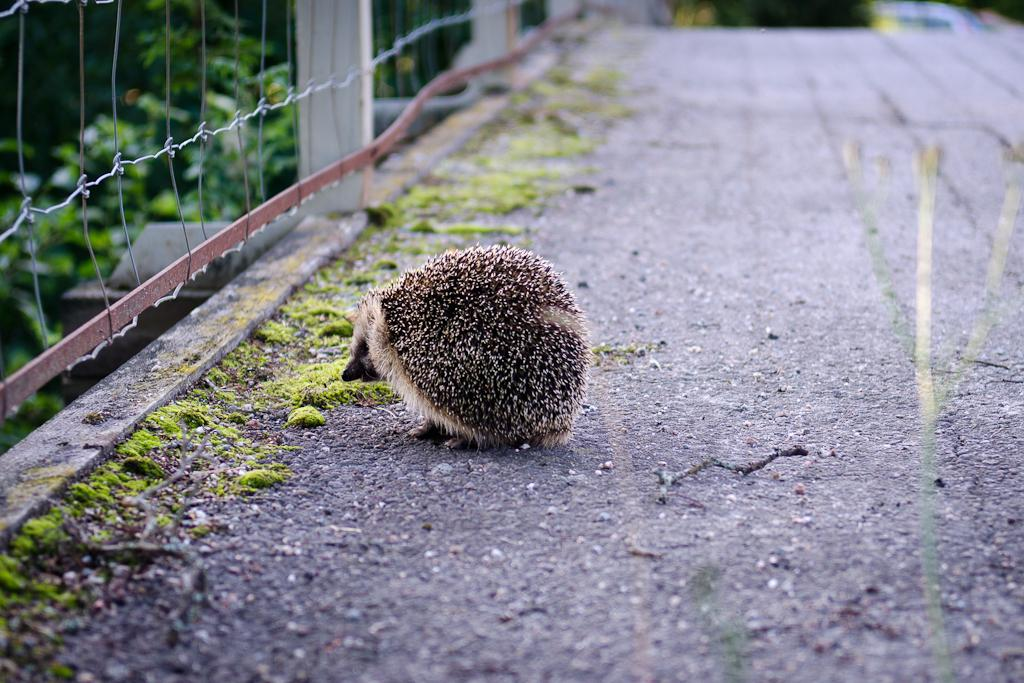What is on the road in the image? There is an animal on the road in the image. What type of natural environment can be seen in the image? Trees and grass are present in the image, indicating a natural environment. Can you describe the fence in the image? There is a fence attached to three poles in the image. What type of company is represented by the animal in the image? There is no company represented by the animal in the image; it is simply an animal on the road. Can you describe the tongue of the deer in the image? There is no deer present in the image, and therefore no tongue to describe. 